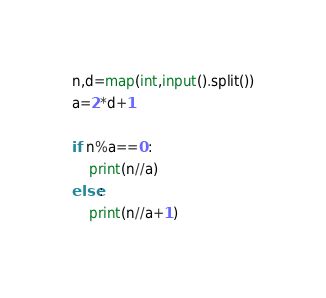<code> <loc_0><loc_0><loc_500><loc_500><_Python_>n,d=map(int,input().split())
a=2*d+1

if n%a==0:
    print(n//a)
else:
    print(n//a+1)
</code> 